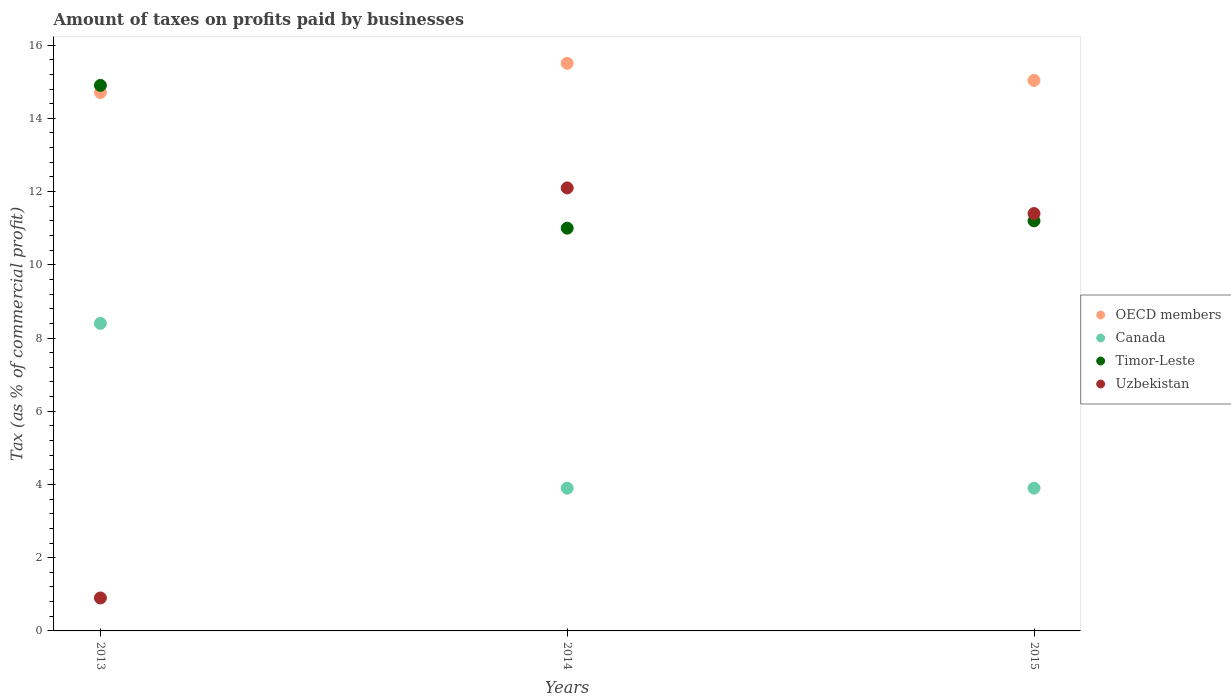How many different coloured dotlines are there?
Provide a succinct answer. 4. Is the number of dotlines equal to the number of legend labels?
Your answer should be very brief. Yes. What is the percentage of taxes paid by businesses in OECD members in 2014?
Provide a succinct answer. 15.5. Across all years, what is the minimum percentage of taxes paid by businesses in Timor-Leste?
Give a very brief answer. 11. What is the total percentage of taxes paid by businesses in Timor-Leste in the graph?
Ensure brevity in your answer.  37.1. What is the average percentage of taxes paid by businesses in OECD members per year?
Provide a succinct answer. 15.08. In how many years, is the percentage of taxes paid by businesses in OECD members greater than 14.8 %?
Make the answer very short. 2. What is the ratio of the percentage of taxes paid by businesses in Uzbekistan in 2013 to that in 2015?
Your answer should be very brief. 0.08. What is the difference between the highest and the second highest percentage of taxes paid by businesses in Uzbekistan?
Make the answer very short. 0.7. What is the difference between the highest and the lowest percentage of taxes paid by businesses in Canada?
Make the answer very short. 4.5. In how many years, is the percentage of taxes paid by businesses in Timor-Leste greater than the average percentage of taxes paid by businesses in Timor-Leste taken over all years?
Offer a very short reply. 1. Is the sum of the percentage of taxes paid by businesses in Timor-Leste in 2013 and 2014 greater than the maximum percentage of taxes paid by businesses in Uzbekistan across all years?
Offer a very short reply. Yes. Is it the case that in every year, the sum of the percentage of taxes paid by businesses in OECD members and percentage of taxes paid by businesses in Uzbekistan  is greater than the sum of percentage of taxes paid by businesses in Timor-Leste and percentage of taxes paid by businesses in Canada?
Give a very brief answer. Yes. Is it the case that in every year, the sum of the percentage of taxes paid by businesses in Timor-Leste and percentage of taxes paid by businesses in Uzbekistan  is greater than the percentage of taxes paid by businesses in OECD members?
Keep it short and to the point. Yes. Does the percentage of taxes paid by businesses in Canada monotonically increase over the years?
Your response must be concise. No. How many dotlines are there?
Provide a short and direct response. 4. What is the difference between two consecutive major ticks on the Y-axis?
Your answer should be very brief. 2. Are the values on the major ticks of Y-axis written in scientific E-notation?
Give a very brief answer. No. Does the graph contain grids?
Ensure brevity in your answer.  No. Where does the legend appear in the graph?
Provide a short and direct response. Center right. How are the legend labels stacked?
Give a very brief answer. Vertical. What is the title of the graph?
Keep it short and to the point. Amount of taxes on profits paid by businesses. Does "Palau" appear as one of the legend labels in the graph?
Provide a short and direct response. No. What is the label or title of the X-axis?
Your answer should be very brief. Years. What is the label or title of the Y-axis?
Give a very brief answer. Tax (as % of commercial profit). What is the Tax (as % of commercial profit) of OECD members in 2013?
Your answer should be compact. 14.71. What is the Tax (as % of commercial profit) in Canada in 2013?
Ensure brevity in your answer.  8.4. What is the Tax (as % of commercial profit) of Timor-Leste in 2013?
Your answer should be very brief. 14.9. What is the Tax (as % of commercial profit) in Uzbekistan in 2013?
Make the answer very short. 0.9. What is the Tax (as % of commercial profit) in OECD members in 2014?
Ensure brevity in your answer.  15.5. What is the Tax (as % of commercial profit) in Timor-Leste in 2014?
Keep it short and to the point. 11. What is the Tax (as % of commercial profit) in Uzbekistan in 2014?
Offer a very short reply. 12.1. What is the Tax (as % of commercial profit) of OECD members in 2015?
Make the answer very short. 15.04. What is the Tax (as % of commercial profit) in Canada in 2015?
Provide a short and direct response. 3.9. Across all years, what is the maximum Tax (as % of commercial profit) of OECD members?
Your answer should be very brief. 15.5. Across all years, what is the maximum Tax (as % of commercial profit) of Uzbekistan?
Make the answer very short. 12.1. Across all years, what is the minimum Tax (as % of commercial profit) of OECD members?
Offer a terse response. 14.71. Across all years, what is the minimum Tax (as % of commercial profit) of Canada?
Your answer should be very brief. 3.9. Across all years, what is the minimum Tax (as % of commercial profit) of Timor-Leste?
Give a very brief answer. 11. What is the total Tax (as % of commercial profit) in OECD members in the graph?
Your answer should be compact. 45.25. What is the total Tax (as % of commercial profit) in Canada in the graph?
Make the answer very short. 16.2. What is the total Tax (as % of commercial profit) in Timor-Leste in the graph?
Offer a terse response. 37.1. What is the total Tax (as % of commercial profit) in Uzbekistan in the graph?
Your response must be concise. 24.4. What is the difference between the Tax (as % of commercial profit) of OECD members in 2013 and that in 2014?
Your answer should be compact. -0.8. What is the difference between the Tax (as % of commercial profit) of Timor-Leste in 2013 and that in 2014?
Your answer should be very brief. 3.9. What is the difference between the Tax (as % of commercial profit) of OECD members in 2013 and that in 2015?
Offer a very short reply. -0.33. What is the difference between the Tax (as % of commercial profit) in Canada in 2013 and that in 2015?
Give a very brief answer. 4.5. What is the difference between the Tax (as % of commercial profit) in OECD members in 2014 and that in 2015?
Your answer should be compact. 0.47. What is the difference between the Tax (as % of commercial profit) in Timor-Leste in 2014 and that in 2015?
Give a very brief answer. -0.2. What is the difference between the Tax (as % of commercial profit) in OECD members in 2013 and the Tax (as % of commercial profit) in Canada in 2014?
Your answer should be very brief. 10.81. What is the difference between the Tax (as % of commercial profit) of OECD members in 2013 and the Tax (as % of commercial profit) of Timor-Leste in 2014?
Keep it short and to the point. 3.71. What is the difference between the Tax (as % of commercial profit) of OECD members in 2013 and the Tax (as % of commercial profit) of Uzbekistan in 2014?
Your answer should be compact. 2.61. What is the difference between the Tax (as % of commercial profit) in Canada in 2013 and the Tax (as % of commercial profit) in Timor-Leste in 2014?
Offer a terse response. -2.6. What is the difference between the Tax (as % of commercial profit) of Timor-Leste in 2013 and the Tax (as % of commercial profit) of Uzbekistan in 2014?
Ensure brevity in your answer.  2.8. What is the difference between the Tax (as % of commercial profit) of OECD members in 2013 and the Tax (as % of commercial profit) of Canada in 2015?
Make the answer very short. 10.81. What is the difference between the Tax (as % of commercial profit) of OECD members in 2013 and the Tax (as % of commercial profit) of Timor-Leste in 2015?
Your response must be concise. 3.51. What is the difference between the Tax (as % of commercial profit) in OECD members in 2013 and the Tax (as % of commercial profit) in Uzbekistan in 2015?
Your answer should be compact. 3.31. What is the difference between the Tax (as % of commercial profit) in Canada in 2013 and the Tax (as % of commercial profit) in Timor-Leste in 2015?
Your answer should be very brief. -2.8. What is the difference between the Tax (as % of commercial profit) in OECD members in 2014 and the Tax (as % of commercial profit) in Canada in 2015?
Ensure brevity in your answer.  11.6. What is the difference between the Tax (as % of commercial profit) in OECD members in 2014 and the Tax (as % of commercial profit) in Timor-Leste in 2015?
Keep it short and to the point. 4.3. What is the difference between the Tax (as % of commercial profit) of OECD members in 2014 and the Tax (as % of commercial profit) of Uzbekistan in 2015?
Make the answer very short. 4.1. What is the difference between the Tax (as % of commercial profit) in Canada in 2014 and the Tax (as % of commercial profit) in Timor-Leste in 2015?
Offer a very short reply. -7.3. What is the difference between the Tax (as % of commercial profit) in Canada in 2014 and the Tax (as % of commercial profit) in Uzbekistan in 2015?
Keep it short and to the point. -7.5. What is the average Tax (as % of commercial profit) in OECD members per year?
Offer a terse response. 15.08. What is the average Tax (as % of commercial profit) of Timor-Leste per year?
Your response must be concise. 12.37. What is the average Tax (as % of commercial profit) of Uzbekistan per year?
Your answer should be very brief. 8.13. In the year 2013, what is the difference between the Tax (as % of commercial profit) of OECD members and Tax (as % of commercial profit) of Canada?
Your answer should be very brief. 6.31. In the year 2013, what is the difference between the Tax (as % of commercial profit) in OECD members and Tax (as % of commercial profit) in Timor-Leste?
Your answer should be very brief. -0.19. In the year 2013, what is the difference between the Tax (as % of commercial profit) of OECD members and Tax (as % of commercial profit) of Uzbekistan?
Your response must be concise. 13.81. In the year 2014, what is the difference between the Tax (as % of commercial profit) in OECD members and Tax (as % of commercial profit) in Canada?
Your answer should be compact. 11.6. In the year 2014, what is the difference between the Tax (as % of commercial profit) in OECD members and Tax (as % of commercial profit) in Timor-Leste?
Offer a very short reply. 4.5. In the year 2014, what is the difference between the Tax (as % of commercial profit) in OECD members and Tax (as % of commercial profit) in Uzbekistan?
Your response must be concise. 3.4. In the year 2014, what is the difference between the Tax (as % of commercial profit) of Canada and Tax (as % of commercial profit) of Timor-Leste?
Provide a short and direct response. -7.1. In the year 2014, what is the difference between the Tax (as % of commercial profit) of Canada and Tax (as % of commercial profit) of Uzbekistan?
Give a very brief answer. -8.2. In the year 2015, what is the difference between the Tax (as % of commercial profit) of OECD members and Tax (as % of commercial profit) of Canada?
Make the answer very short. 11.14. In the year 2015, what is the difference between the Tax (as % of commercial profit) in OECD members and Tax (as % of commercial profit) in Timor-Leste?
Ensure brevity in your answer.  3.84. In the year 2015, what is the difference between the Tax (as % of commercial profit) in OECD members and Tax (as % of commercial profit) in Uzbekistan?
Give a very brief answer. 3.64. In the year 2015, what is the difference between the Tax (as % of commercial profit) of Canada and Tax (as % of commercial profit) of Uzbekistan?
Offer a terse response. -7.5. What is the ratio of the Tax (as % of commercial profit) of OECD members in 2013 to that in 2014?
Your response must be concise. 0.95. What is the ratio of the Tax (as % of commercial profit) of Canada in 2013 to that in 2014?
Give a very brief answer. 2.15. What is the ratio of the Tax (as % of commercial profit) in Timor-Leste in 2013 to that in 2014?
Your answer should be compact. 1.35. What is the ratio of the Tax (as % of commercial profit) in Uzbekistan in 2013 to that in 2014?
Your answer should be very brief. 0.07. What is the ratio of the Tax (as % of commercial profit) in OECD members in 2013 to that in 2015?
Ensure brevity in your answer.  0.98. What is the ratio of the Tax (as % of commercial profit) of Canada in 2013 to that in 2015?
Your response must be concise. 2.15. What is the ratio of the Tax (as % of commercial profit) of Timor-Leste in 2013 to that in 2015?
Give a very brief answer. 1.33. What is the ratio of the Tax (as % of commercial profit) of Uzbekistan in 2013 to that in 2015?
Ensure brevity in your answer.  0.08. What is the ratio of the Tax (as % of commercial profit) in OECD members in 2014 to that in 2015?
Your answer should be very brief. 1.03. What is the ratio of the Tax (as % of commercial profit) in Canada in 2014 to that in 2015?
Give a very brief answer. 1. What is the ratio of the Tax (as % of commercial profit) in Timor-Leste in 2014 to that in 2015?
Keep it short and to the point. 0.98. What is the ratio of the Tax (as % of commercial profit) of Uzbekistan in 2014 to that in 2015?
Provide a short and direct response. 1.06. What is the difference between the highest and the second highest Tax (as % of commercial profit) in OECD members?
Your answer should be very brief. 0.47. What is the difference between the highest and the second highest Tax (as % of commercial profit) in Canada?
Give a very brief answer. 4.5. What is the difference between the highest and the second highest Tax (as % of commercial profit) in Timor-Leste?
Your answer should be very brief. 3.7. What is the difference between the highest and the second highest Tax (as % of commercial profit) in Uzbekistan?
Ensure brevity in your answer.  0.7. What is the difference between the highest and the lowest Tax (as % of commercial profit) of OECD members?
Your answer should be compact. 0.8. What is the difference between the highest and the lowest Tax (as % of commercial profit) of Canada?
Offer a terse response. 4.5. What is the difference between the highest and the lowest Tax (as % of commercial profit) of Timor-Leste?
Your answer should be compact. 3.9. 